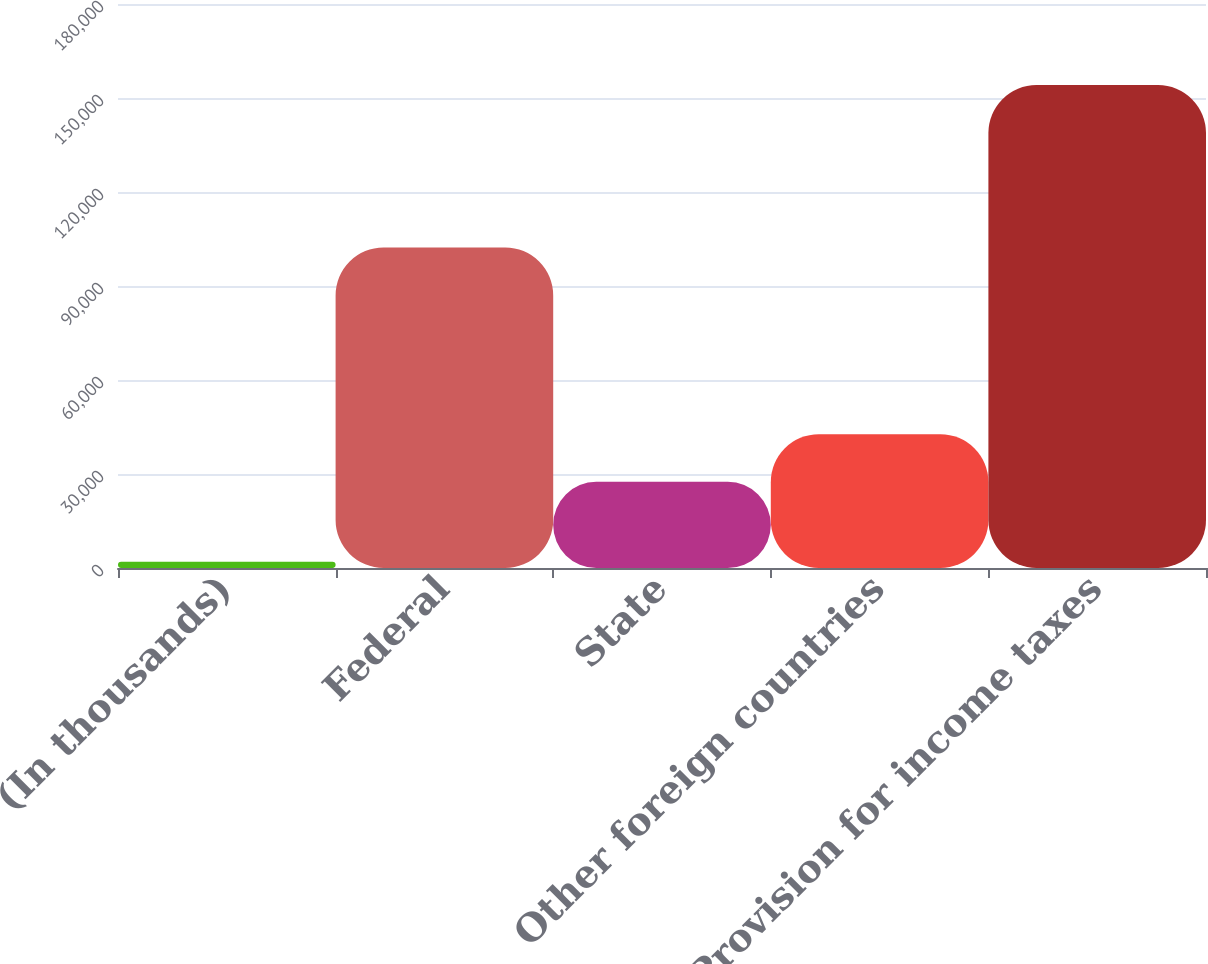Convert chart to OTSL. <chart><loc_0><loc_0><loc_500><loc_500><bar_chart><fcel>(In thousands)<fcel>Federal<fcel>State<fcel>Other foreign countries<fcel>Provision for income taxes<nl><fcel>2015<fcel>102317<fcel>27500<fcel>42709.7<fcel>154112<nl></chart> 